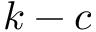<formula> <loc_0><loc_0><loc_500><loc_500>k - c</formula> 